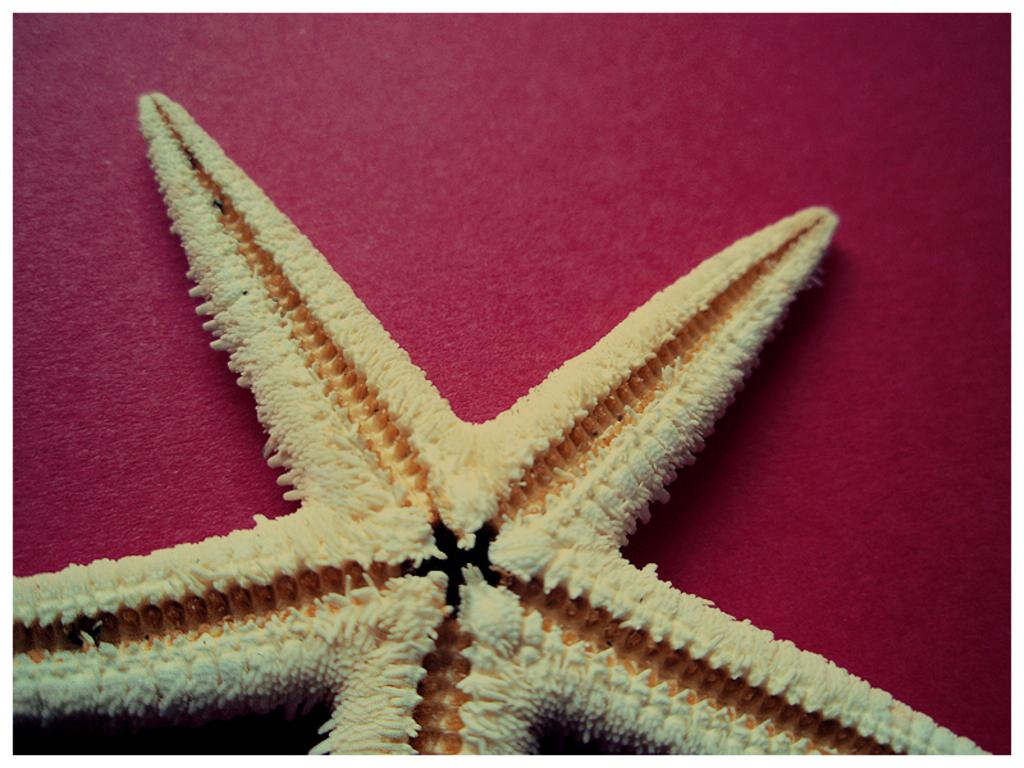What is the main subject of the image? The main subject of the image is a starfish. What color is the surface on which the starfish is placed? The starfish is on a red color surface. How many cows can be seen in the image? There are no cows present in the image; it features a starfish on a red surface. Is there a lock visible in the image? There is no lock present in the image; it only features a starfish on a red surface. 